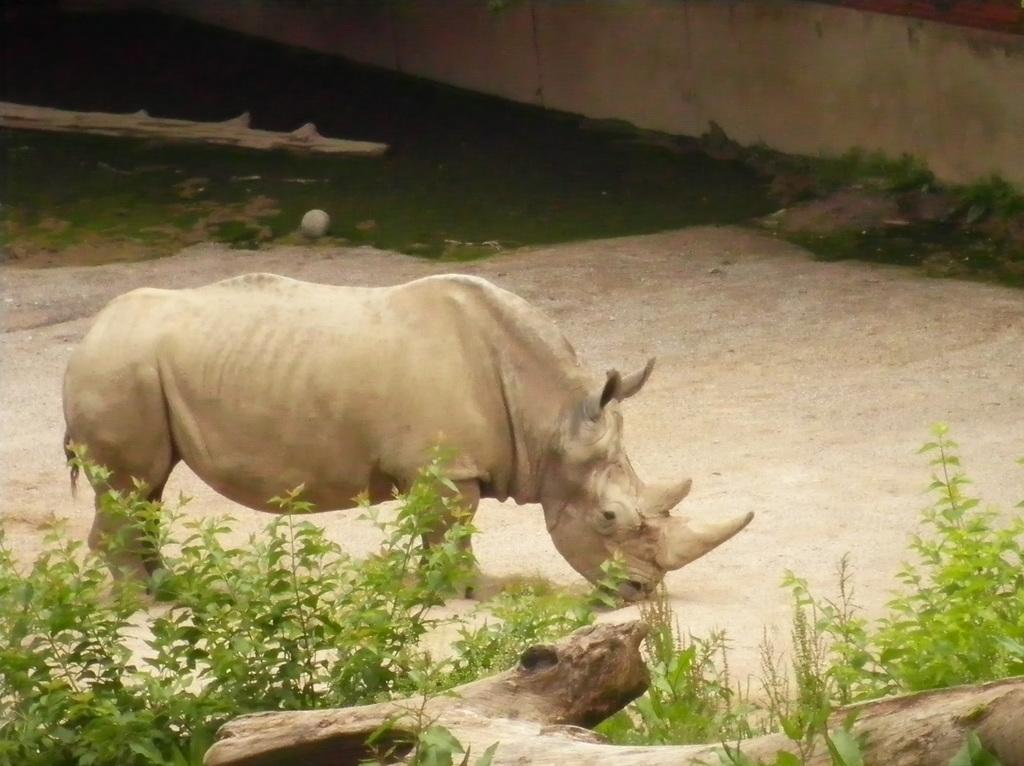What type of animal is in the image? There is a Rhinoceros in the image. What type of vegetation is present in the image? There is grass in the image. What type of natural material is visible in the image? There is a wood in the image. What type of man-made structure is present in the image? There is a wall in the image. What type of voice can be heard coming from the Rhinoceros in the image? Rhinoceroses do not have the ability to produce or communicate with voice, so there is no voice present in the image. What type of bell is hanging from the Rhinoceros in the image? There is no bell present in the image, and the Rhinoceros is not holding or wearing any bell. 